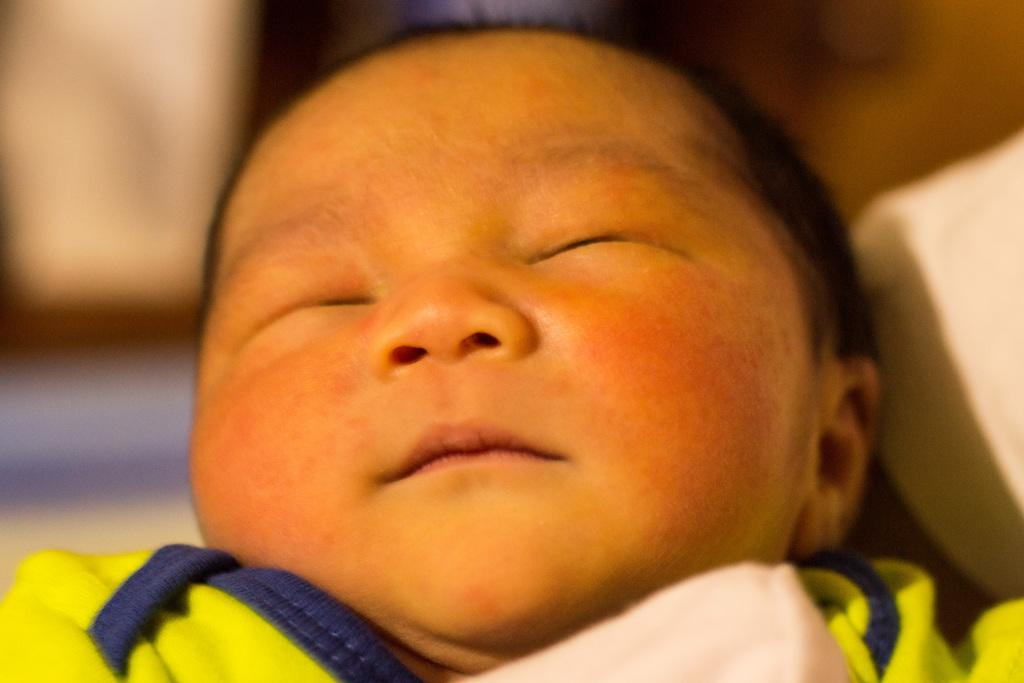What is the main subject in the foreground of the image? There is a baby in the foreground of the image. What is the baby wearing? The baby is wearing a green dress. Can you describe the background of the image? The background of the image is blurred. How many oranges can be seen in the baby's grip in the image? There are no oranges present in the image, and the baby is not holding anything in their grip. 